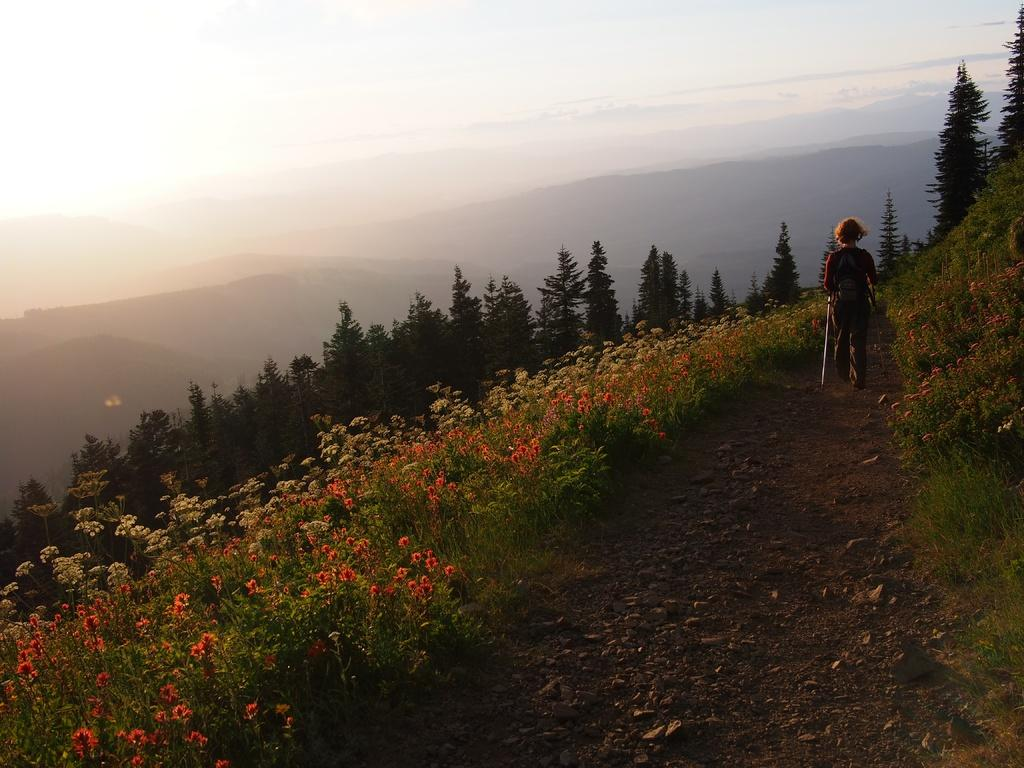What type of vegetation can be seen in the image? There are flower plants and trees in the image. What is the person in the image doing? The person is walking on the ground in the image. What can be seen in the background of the image? There are mountains and the sky visible in the background of the image. How many cars can be seen parked near the trees in the image? There are no cars present in the image; it features flower plants, trees, a person walking, mountains, and the sky. What type of leaf is falling from the tree in the image? There is no leaf falling from the tree in the image; it only shows flower plants, trees, a person walking, mountains, and the sky. 